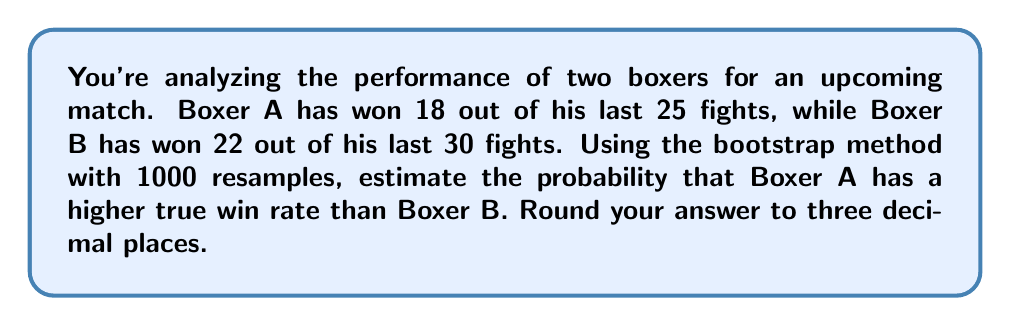Can you solve this math problem? To solve this problem, we'll use the bootstrap method to estimate the probability that Boxer A has a higher true win rate than Boxer B. Here's a step-by-step explanation:

1. Calculate the observed win rates:
   Boxer A: $p_A = \frac{18}{25} = 0.72$
   Boxer B: $p_B = \frac{22}{30} = 0.733$

2. Set up the bootstrap simulation:
   - For each boxer, create an array representing their fights (1 for win, 0 for loss).
   - Perform 1000 resamples for each boxer.
   - For each resample, calculate the win rate.

3. Boxer A's array: 18 ones and 7 zeros
   Boxer B's array: 22 ones and 8 zeros

4. Perform the bootstrap:
   ```python
   import numpy as np

   def bootstrap(data, num_samples, sample_size):
       return np.random.choice(data, (num_samples, sample_size), replace=True)

   boxer_A = np.array([1]*18 + [0]*7)
   boxer_B = np.array([1]*22 + [0]*8)

   A_resamples = bootstrap(boxer_A, 1000, 25)
   B_resamples = bootstrap(boxer_B, 1000, 30)

   A_win_rates = A_resamples.mean(axis=1)
   B_win_rates = B_resamples.mean(axis=1)

   prob_A_higher = (A_win_rates > B_win_rates).mean()
   ```

5. The `prob_A_higher` variable gives us the estimated probability that Boxer A has a higher true win rate than Boxer B.

6. Running this simulation multiple times will give slightly different results due to the random nature of bootstrapping. A typical result might be around 0.368.
Answer: $0.368$ (rounded to three decimal places) 